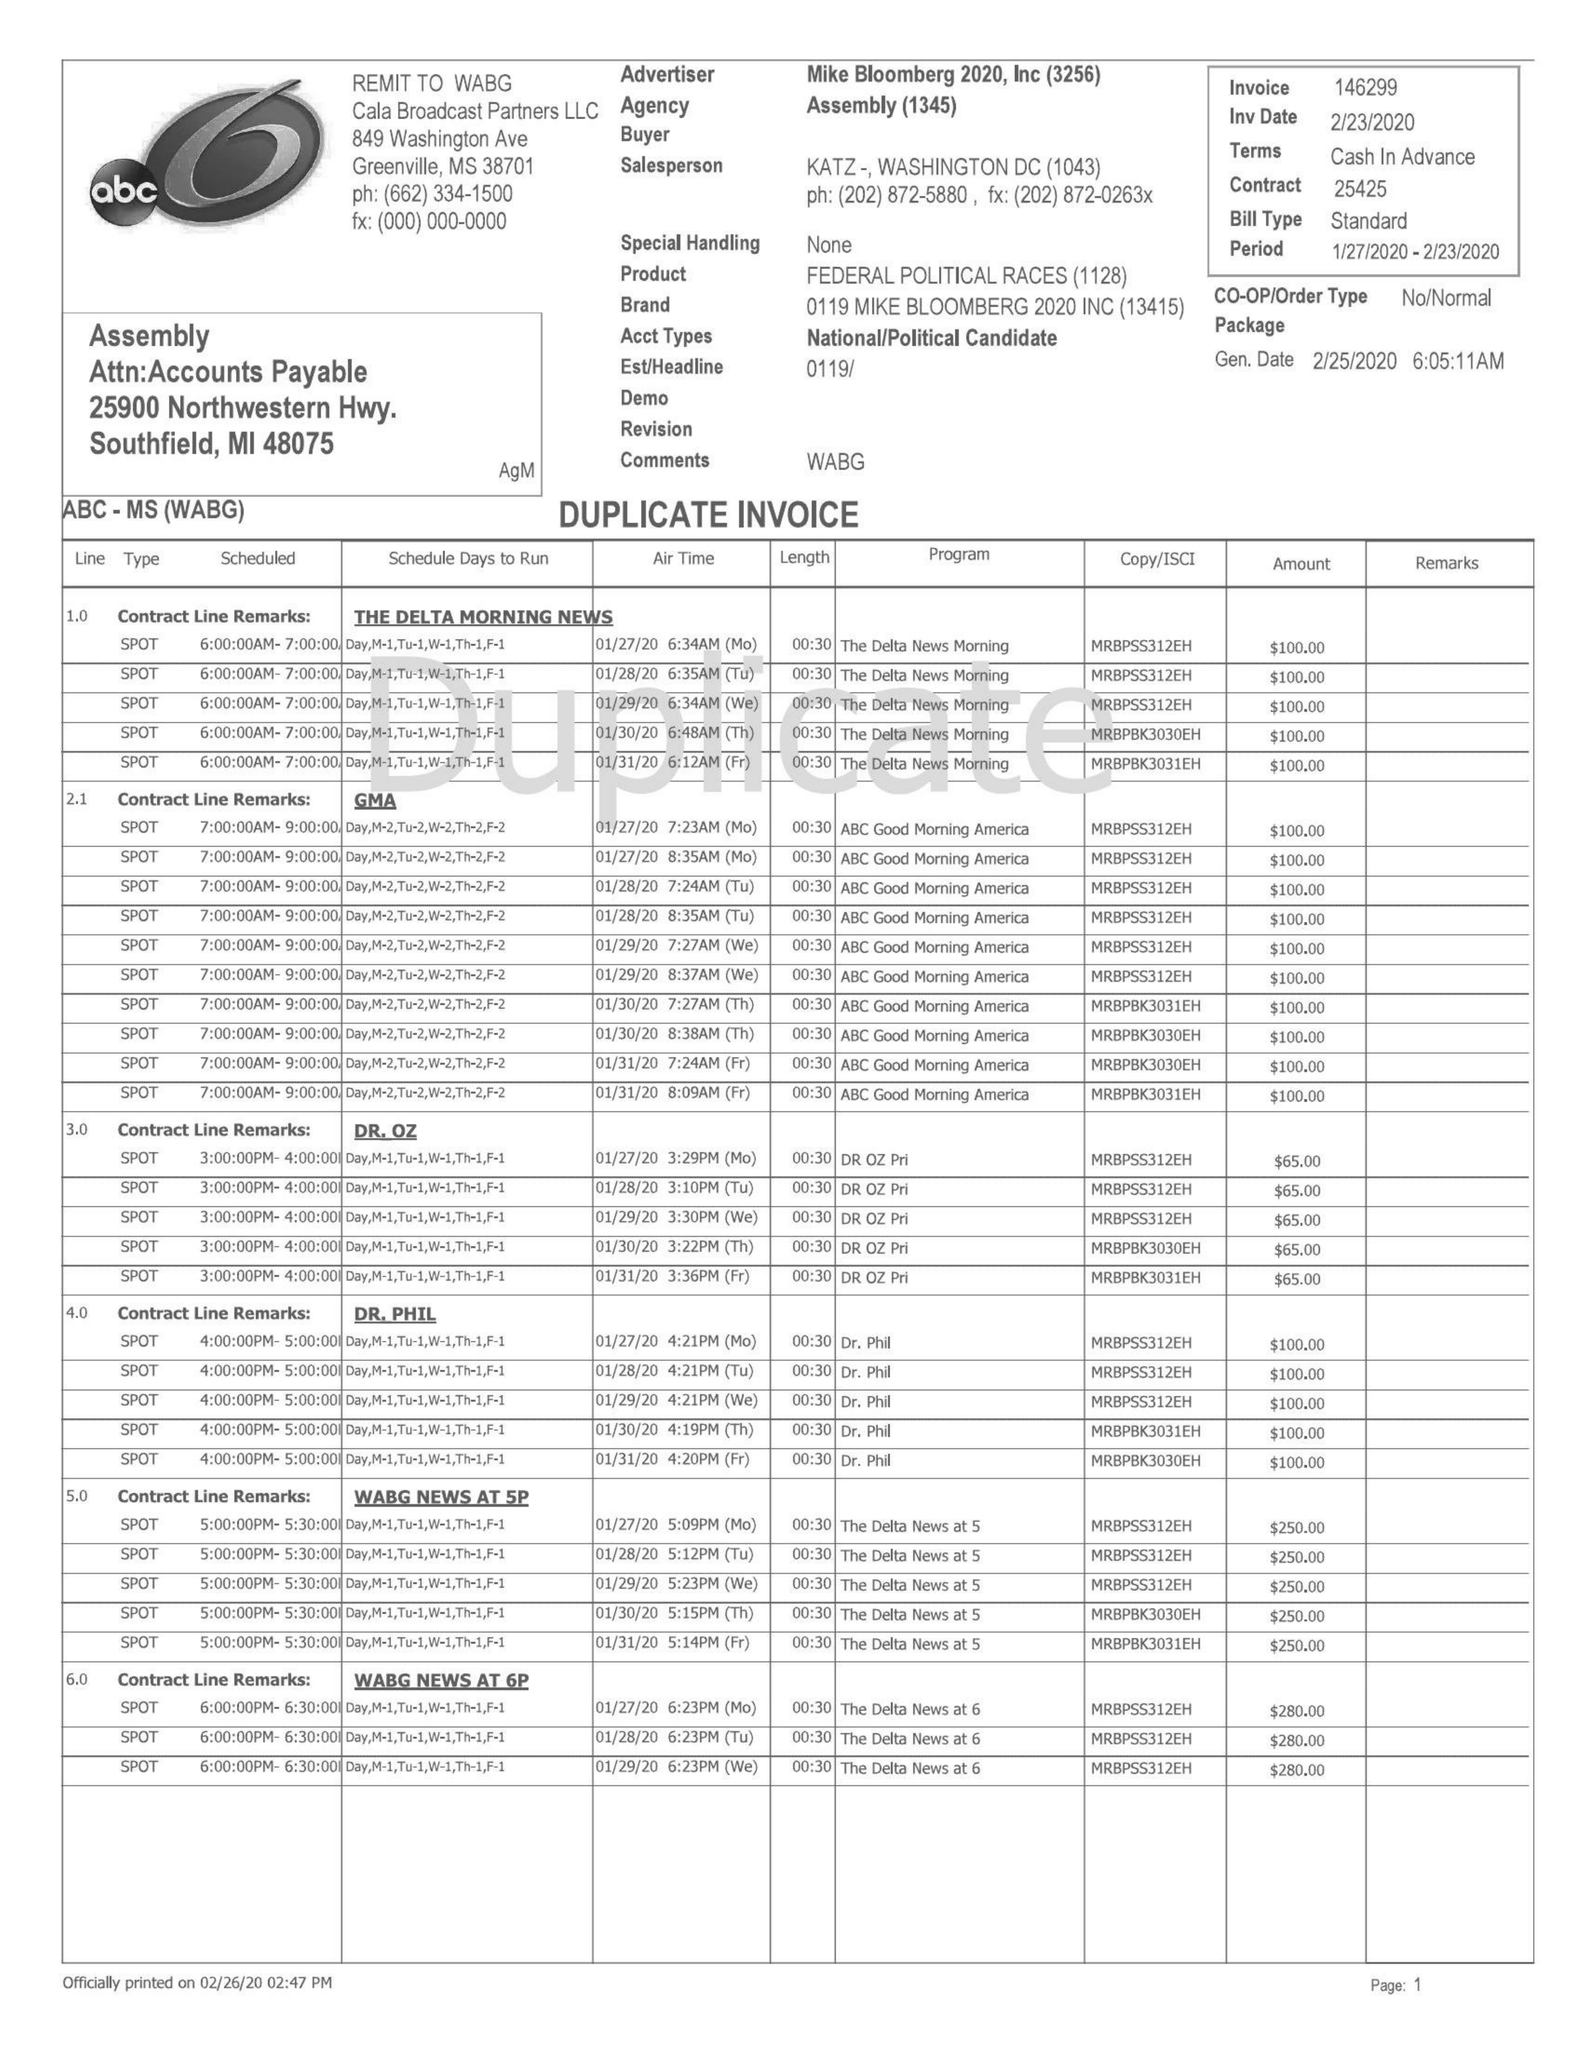What is the value for the contract_num?
Answer the question using a single word or phrase. 25425 